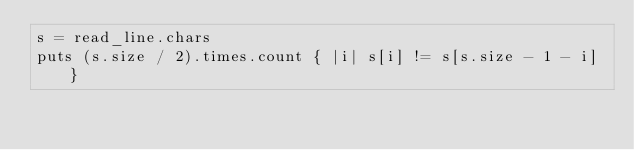<code> <loc_0><loc_0><loc_500><loc_500><_Crystal_>s = read_line.chars
puts (s.size / 2).times.count { |i| s[i] != s[s.size - 1 - i] }
</code> 